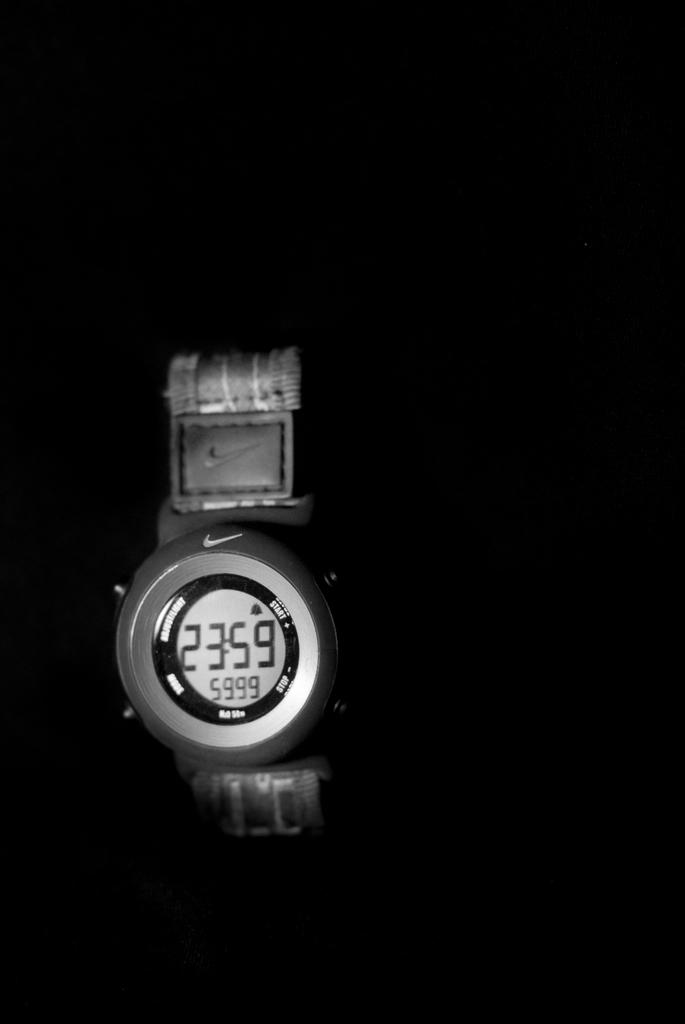<image>
Provide a brief description of the given image. A silver watch with a nike symbol on it has the time 23:59 on it. 